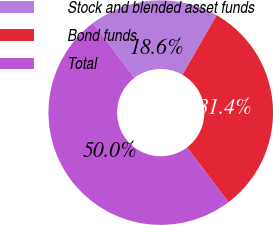Convert chart. <chart><loc_0><loc_0><loc_500><loc_500><pie_chart><fcel>Stock and blended asset funds<fcel>Bond funds<fcel>Total<nl><fcel>18.6%<fcel>31.4%<fcel>50.0%<nl></chart> 